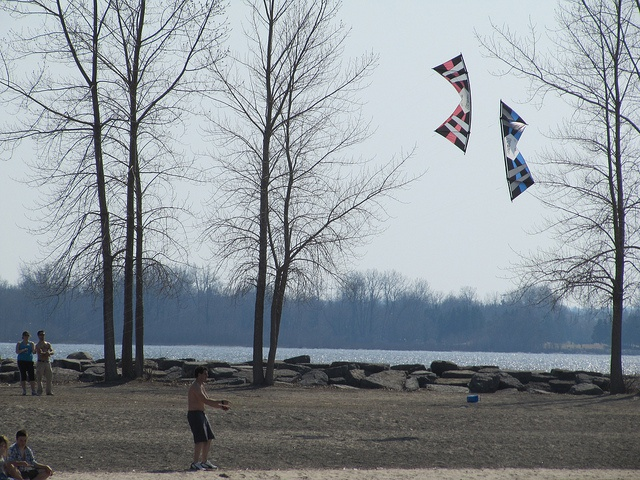Describe the objects in this image and their specific colors. I can see kite in darkgray, black, lightgray, and brown tones, people in darkgray, black, and gray tones, kite in darkgray, black, and gray tones, people in darkgray, black, and gray tones, and people in darkgray, black, and purple tones in this image. 